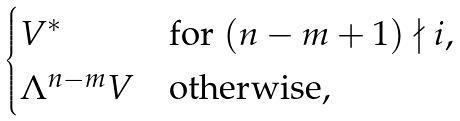<formula> <loc_0><loc_0><loc_500><loc_500>\begin{cases} V ^ { * } & \text {for } ( n - m + 1 ) \nmid i , \\ \Lambda ^ { n - m } V & \text {otherwise,} \end{cases}</formula> 